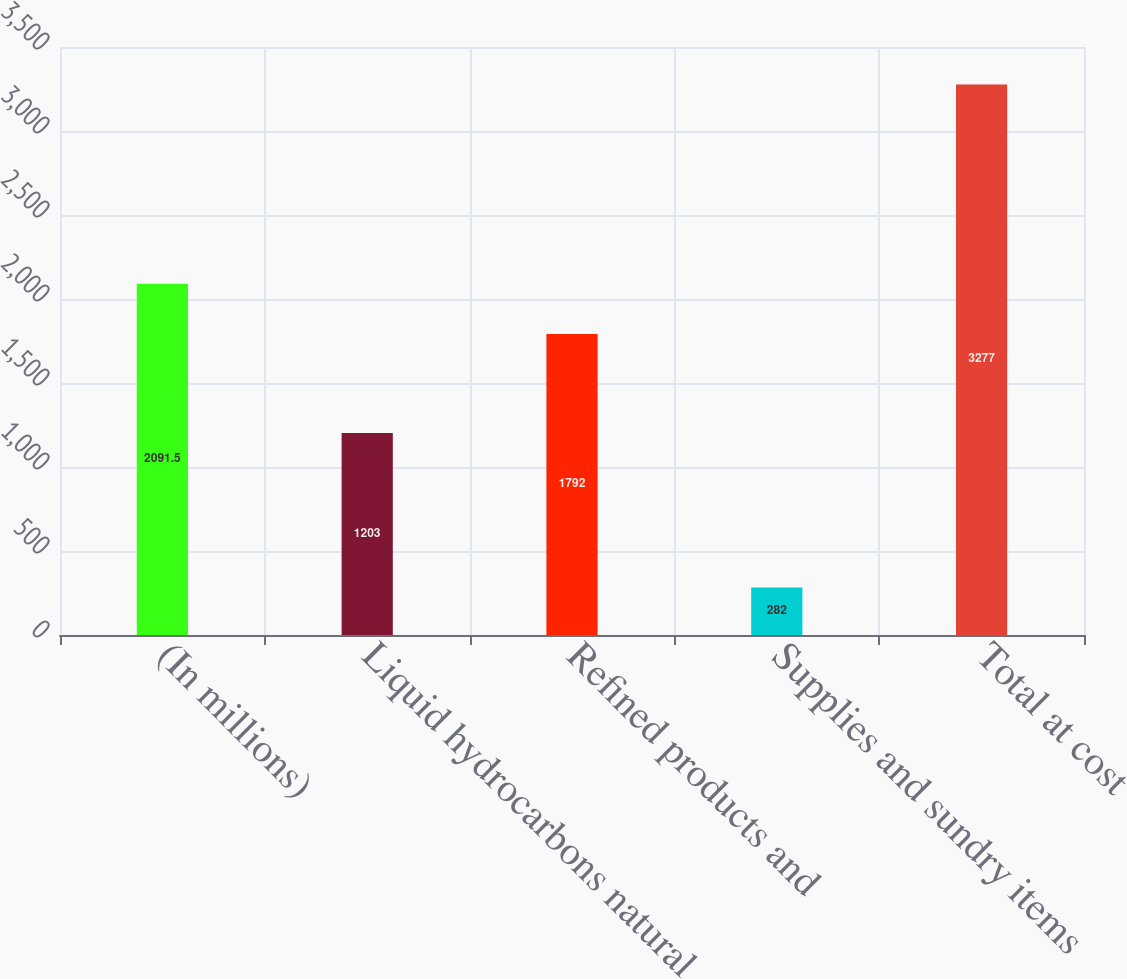<chart> <loc_0><loc_0><loc_500><loc_500><bar_chart><fcel>(In millions)<fcel>Liquid hydrocarbons natural<fcel>Refined products and<fcel>Supplies and sundry items<fcel>Total at cost<nl><fcel>2091.5<fcel>1203<fcel>1792<fcel>282<fcel>3277<nl></chart> 